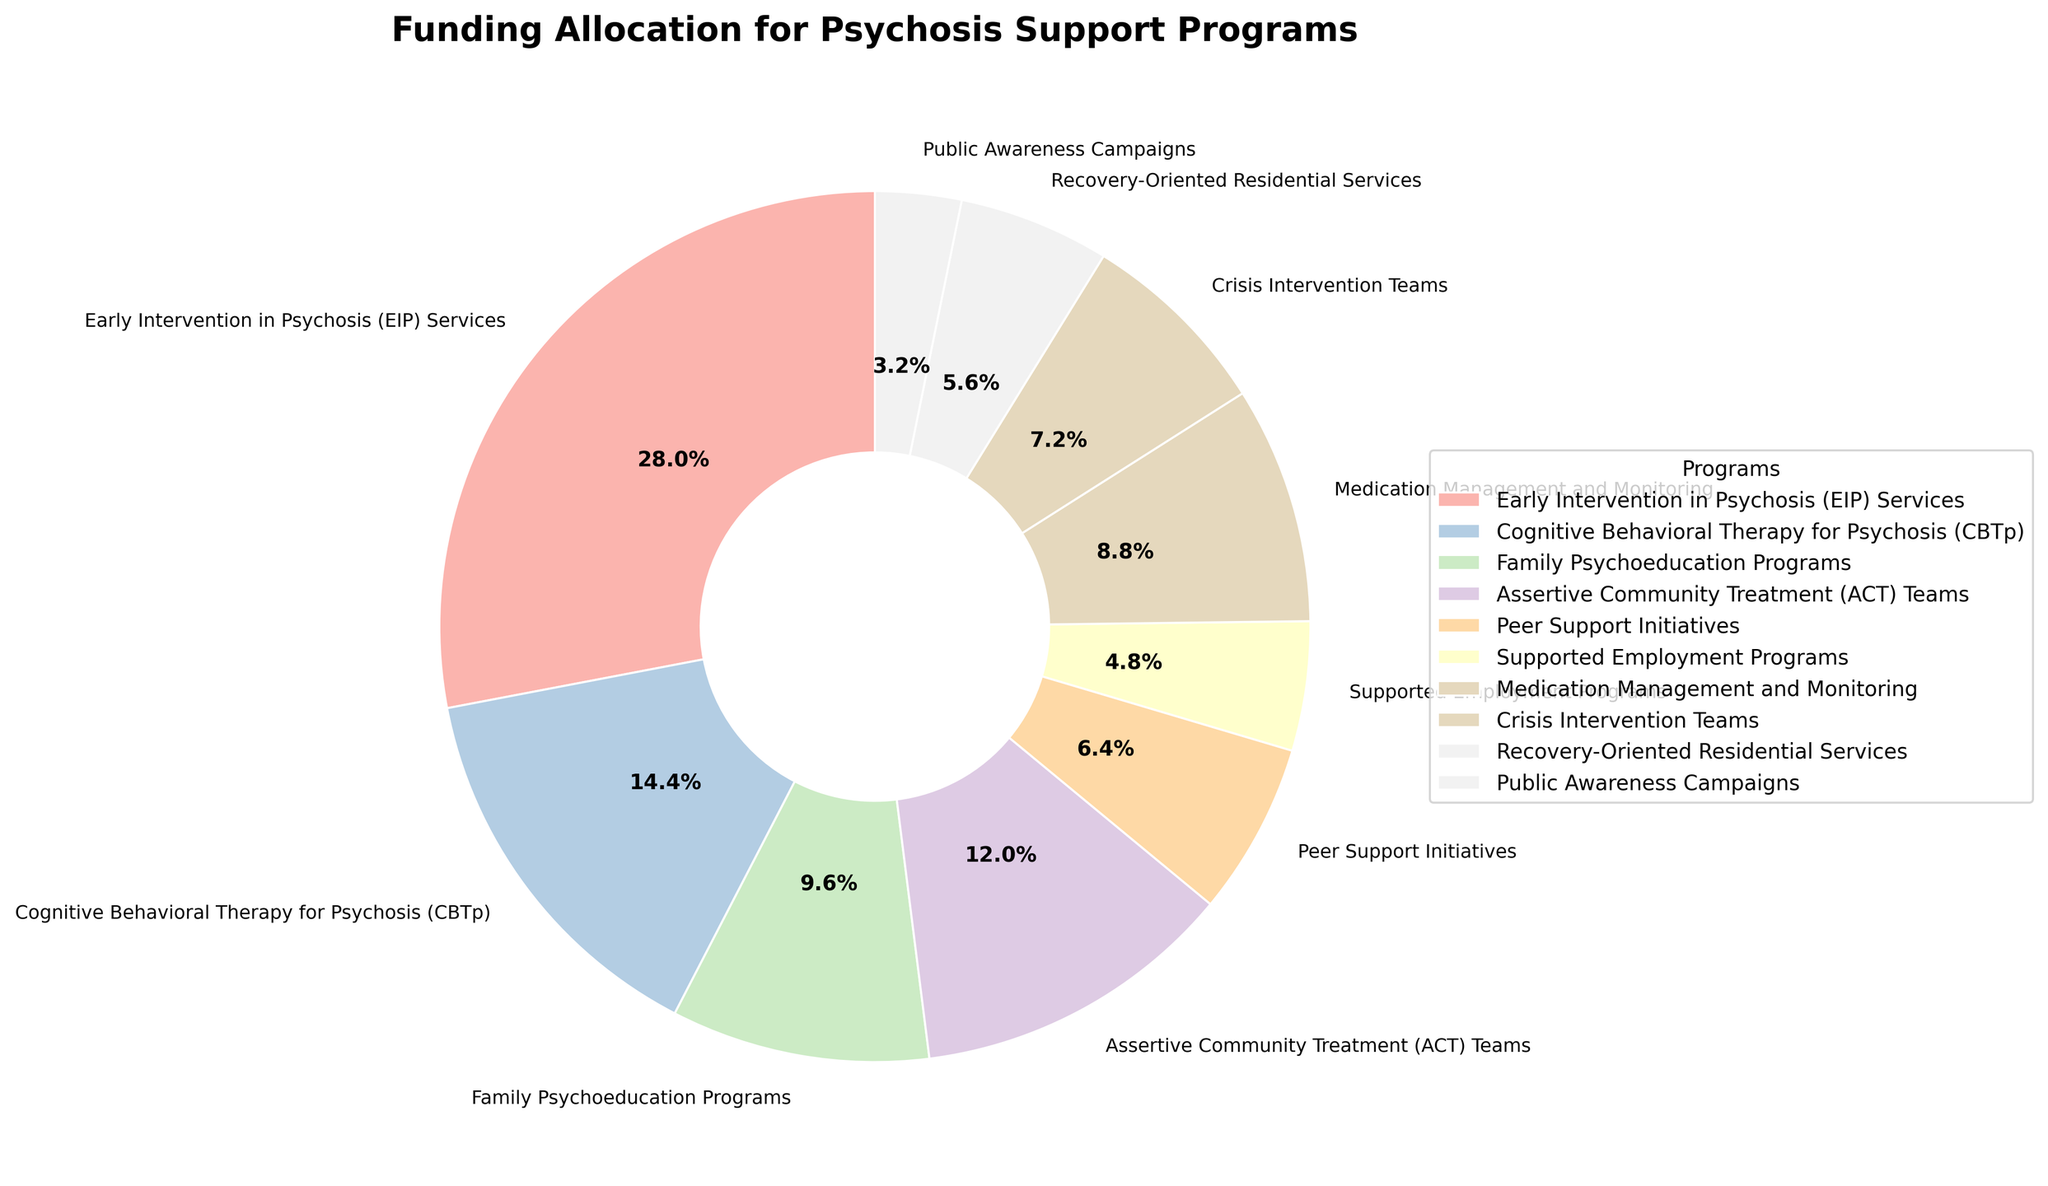What percentage of funding is allocated to Cognitive Behavioral Therapy for Psychosis (CBTp)? Find CBTp in the list of programs and note that its funding allocation is 18%. This value is directly visible from the chart.
Answer: 18% Which program has the highest allocation of funds? Look for the program with the largest segment in the pie chart. Early Intervention in Psychosis (EIP) Services takes up the biggest portion at 35%.
Answer: Early Intervention in Psychosis (EIP) Services How much more funding does Early Intervention in Psychosis (EIP) Services receive compared to Family Psychoeducation Programs? EIP receives 35%, and Family Psychoeducation receives 12%. The difference is calculated as 35% - 12%.
Answer: 23% Compare the funding allocations for Assertive Community Treatment (ACT) Teams and Medication Management and Monitoring. Which has a higher allocation and by how much? ACT Teams have 15%, while Medication Management and Monitoring have 11%. Subtract 11% from 15% to determine the difference.
Answer: ACT Teams by 4% What is the combined percentage of funding for Peer Support Initiatives and Crisis Intervention Teams? Peer Support Initiatives receive 8%, and Crisis Intervention Teams receive 9%. The combined percentage is 8% + 9%.
Answer: 17% Which program receives the least funding? Identify the smallest segment in the pie chart. Public Awareness Campaigns receive the smallest portion at 4%.
Answer: Public Awareness Campaigns Is the funding allocation for Supported Employment Programs greater than or less than 10%? Find Supported Employment Programs, which receive 6% of the funding, which is less than 10%.
Answer: Less than 10% Is the sum of the funding allocations for Recovery-Oriented Residential Services and Public Awareness Campaigns greater than that for Cognitive Behavioral Therapy for Psychosis (CBTp)? Recovery-Oriented Residential Services is 7%, and Public Awareness Campaigns is 4%, totaling 11%. CBTp receives 18%, so 11% is less than 18%.
Answer: No What percentage of the total funding is allocated to programs receiving less than 10% funds each? Identify all programs with allocations less than 10%: Peer Support Initiatives (8%), Supported Employment Programs (6%), Medication Management and Monitoring (11%), Crisis Intervention Teams (9%), Recovery-Oriented Residential Services (7%), Public Awareness Campaigns (4%). Sum these percentages: 8% + 6% + 11% + 9% + 7% + 4% = 45%.
Answer: 45% What is the visual difference between the wedges representing Peer Support Initiatives and Supported Employment Programs? Peer Support Initiatives is larger and takes up 8% of the pie, while Supported Employment Programs takes up 6%. Both are different in size.
Answer: Peer Support Initiatives are bigger 